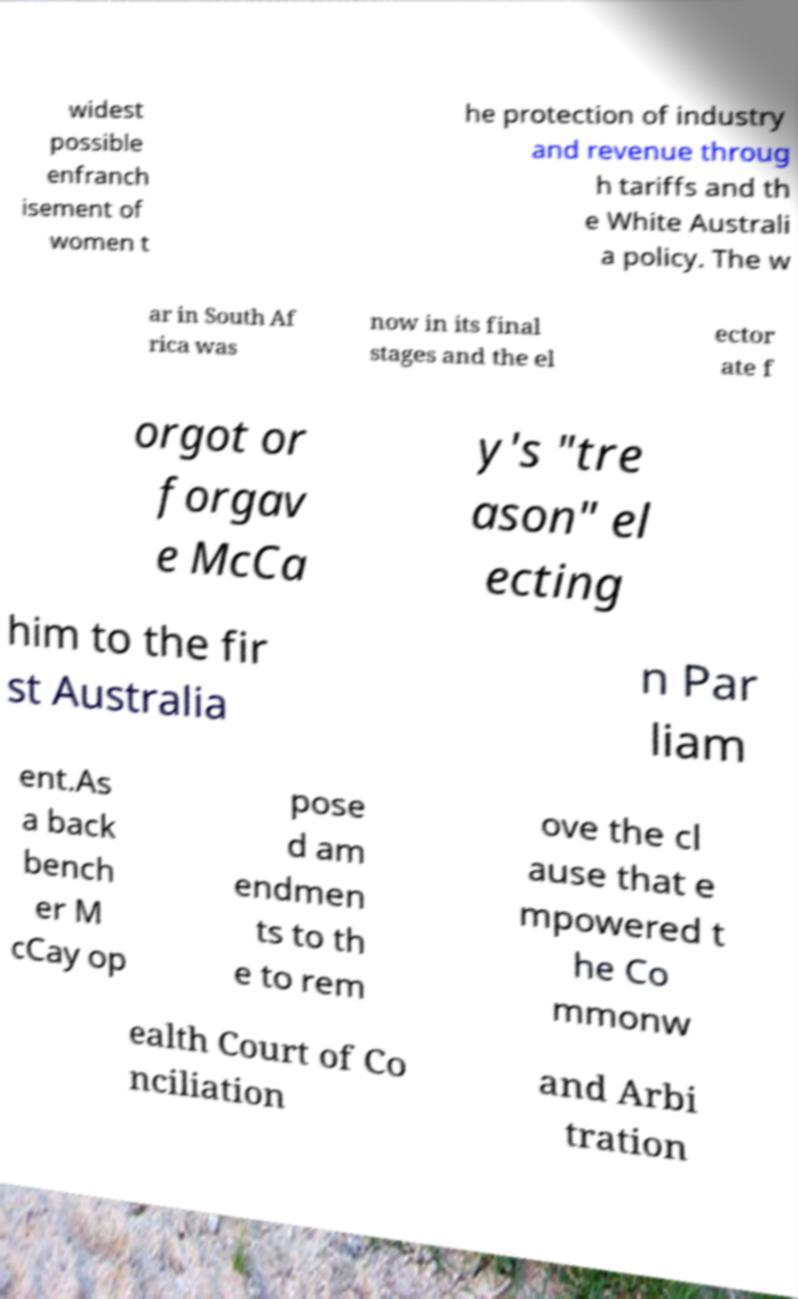Can you accurately transcribe the text from the provided image for me? widest possible enfranch isement of women t he protection of industry and revenue throug h tariffs and th e White Australi a policy. The w ar in South Af rica was now in its final stages and the el ector ate f orgot or forgav e McCa y's "tre ason" el ecting him to the fir st Australia n Par liam ent.As a back bench er M cCay op pose d am endmen ts to th e to rem ove the cl ause that e mpowered t he Co mmonw ealth Court of Co nciliation and Arbi tration 